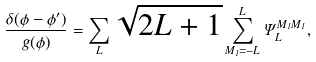Convert formula to latex. <formula><loc_0><loc_0><loc_500><loc_500>\frac { \delta ( \phi - \phi ^ { \prime } ) } { g ( \phi ) } = \sum _ { L } \sqrt { 2 L + 1 } \sum _ { M _ { 1 } = - L } ^ { L } \Psi _ { L } ^ { M _ { 1 } M _ { 1 } } ,</formula> 